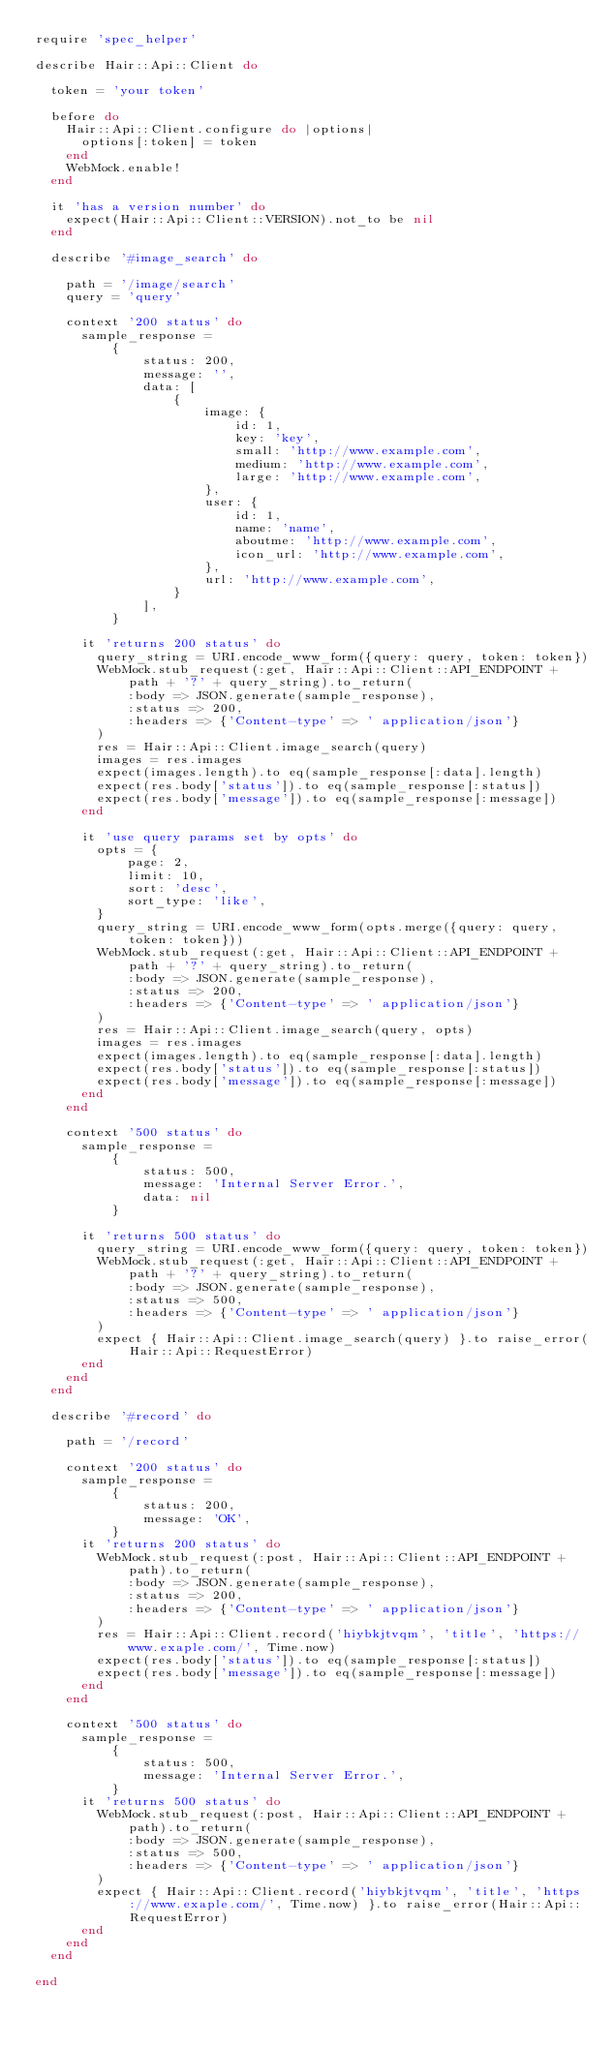<code> <loc_0><loc_0><loc_500><loc_500><_Ruby_>require 'spec_helper'

describe Hair::Api::Client do

  token = 'your token'

  before do
    Hair::Api::Client.configure do |options|
      options[:token] = token
    end
    WebMock.enable!
  end

  it 'has a version number' do
    expect(Hair::Api::Client::VERSION).not_to be nil
  end

  describe '#image_search' do

    path = '/image/search'
    query = 'query'

    context '200 status' do
      sample_response =
          {
              status: 200,
              message: '',
              data: [
                  {
                      image: {
                          id: 1,
                          key: 'key',
                          small: 'http://www.example.com',
                          medium: 'http://www.example.com',
                          large: 'http://www.example.com',
                      },
                      user: {
                          id: 1,
                          name: 'name',
                          aboutme: 'http://www.example.com',
                          icon_url: 'http://www.example.com',
                      },
                      url: 'http://www.example.com',
                  }
              ],
          }

      it 'returns 200 status' do
        query_string = URI.encode_www_form({query: query, token: token})
        WebMock.stub_request(:get, Hair::Api::Client::API_ENDPOINT + path + '?' + query_string).to_return(
            :body => JSON.generate(sample_response),
            :status => 200,
            :headers => {'Content-type' => ' application/json'}
        )
        res = Hair::Api::Client.image_search(query)
        images = res.images
        expect(images.length).to eq(sample_response[:data].length)
        expect(res.body['status']).to eq(sample_response[:status])
        expect(res.body['message']).to eq(sample_response[:message])
      end

      it 'use query params set by opts' do
        opts = {
            page: 2,
            limit: 10,
            sort: 'desc',
            sort_type: 'like',
        }
        query_string = URI.encode_www_form(opts.merge({query: query, token: token}))
        WebMock.stub_request(:get, Hair::Api::Client::API_ENDPOINT + path + '?' + query_string).to_return(
            :body => JSON.generate(sample_response),
            :status => 200,
            :headers => {'Content-type' => ' application/json'}
        )
        res = Hair::Api::Client.image_search(query, opts)
        images = res.images
        expect(images.length).to eq(sample_response[:data].length)
        expect(res.body['status']).to eq(sample_response[:status])
        expect(res.body['message']).to eq(sample_response[:message])
      end
    end

    context '500 status' do
      sample_response =
          {
              status: 500,
              message: 'Internal Server Error.',
              data: nil
          }

      it 'returns 500 status' do
        query_string = URI.encode_www_form({query: query, token: token})
        WebMock.stub_request(:get, Hair::Api::Client::API_ENDPOINT + path + '?' + query_string).to_return(
            :body => JSON.generate(sample_response),
            :status => 500,
            :headers => {'Content-type' => ' application/json'}
        )
        expect { Hair::Api::Client.image_search(query) }.to raise_error(Hair::Api::RequestError)
      end
    end
  end

  describe '#record' do

    path = '/record'

    context '200 status' do
      sample_response =
          {
              status: 200,
              message: 'OK',
          }
      it 'returns 200 status' do
        WebMock.stub_request(:post, Hair::Api::Client::API_ENDPOINT + path).to_return(
            :body => JSON.generate(sample_response),
            :status => 200,
            :headers => {'Content-type' => ' application/json'}
        )
        res = Hair::Api::Client.record('hiybkjtvqm', 'title', 'https://www.exaple.com/', Time.now)
        expect(res.body['status']).to eq(sample_response[:status])
        expect(res.body['message']).to eq(sample_response[:message])
      end
    end

    context '500 status' do
      sample_response =
          {
              status: 500,
              message: 'Internal Server Error.',
          }
      it 'returns 500 status' do
        WebMock.stub_request(:post, Hair::Api::Client::API_ENDPOINT + path).to_return(
            :body => JSON.generate(sample_response),
            :status => 500,
            :headers => {'Content-type' => ' application/json'}
        )
        expect { Hair::Api::Client.record('hiybkjtvqm', 'title', 'https://www.exaple.com/', Time.now) }.to raise_error(Hair::Api::RequestError)
      end
    end
  end

end
</code> 